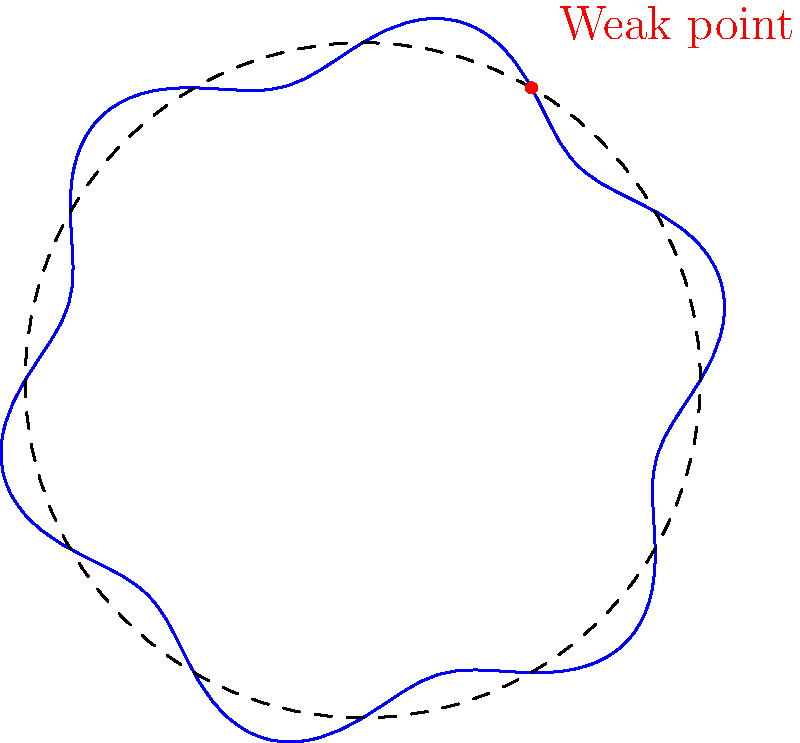In your latest "Star Wars" fan fiction, you've decided to redesign the Death Star with a more complex circular cross-section. The polar equation $r = 5 + 0.5\sin(6\theta)$ describes this new cross-section (in arbitrary units). If a critical weak point is located at $\theta = \frac{\pi}{3}$, what is its distance from the center? To find the distance of the weak point from the center, we need to follow these steps:

1) The given polar equation is $r = 5 + 0.5\sin(6\theta)$.

2) We need to find $r$ when $\theta = \frac{\pi}{3}$.

3) Substitute $\theta = \frac{\pi}{3}$ into the equation:
   $r = 5 + 0.5\sin(6 \cdot \frac{\pi}{3})$

4) Simplify the argument of sine:
   $r = 5 + 0.5\sin(2\pi)$

5) Recall that $\sin(2\pi) = 0$:
   $r = 5 + 0.5 \cdot 0 = 5$

Therefore, the weak point is located at a distance of 5 units from the center of the Death Star's cross-section.
Answer: 5 units 